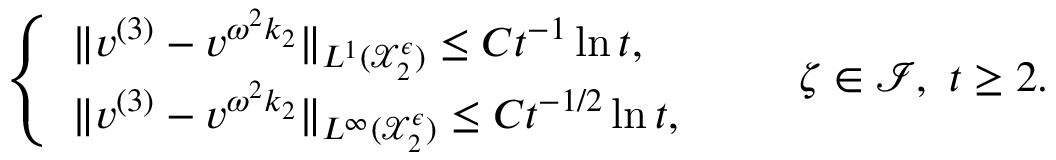Convert formula to latex. <formula><loc_0><loc_0><loc_500><loc_500>\begin{array} { r } { \left \{ \begin{array} { l l } { \| v ^ { ( 3 ) } - v ^ { \omega ^ { 2 } k _ { 2 } } \| _ { L ^ { 1 } ( \mathcal { X } _ { 2 } ^ { \epsilon } ) } \leq C t ^ { - 1 } \ln t , } \\ { \| v ^ { ( 3 ) } - v ^ { \omega ^ { 2 } k _ { 2 } } \| _ { L ^ { \infty } ( \mathcal { X } _ { 2 } ^ { \epsilon } ) } \leq C t ^ { - 1 / 2 } \ln t , } \end{array} \quad \zeta \in \mathcal { I } , \ t \geq 2 . } \end{array}</formula> 